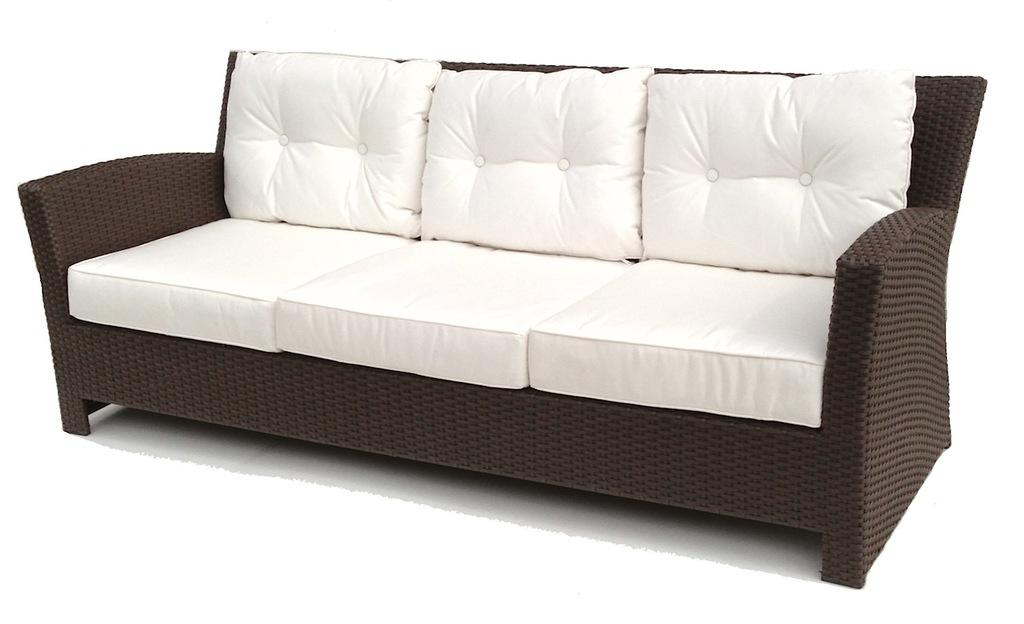What type of furniture is present in the image? There is a couch in the image. What color is the background of the image? The background of the image is white. Can you see a van driving through the image? There is no van present in the image. What type of trick is being performed in the image? There is no trick being performed in the image. Is there a boat visible in the image? There is no boat present in the image. 